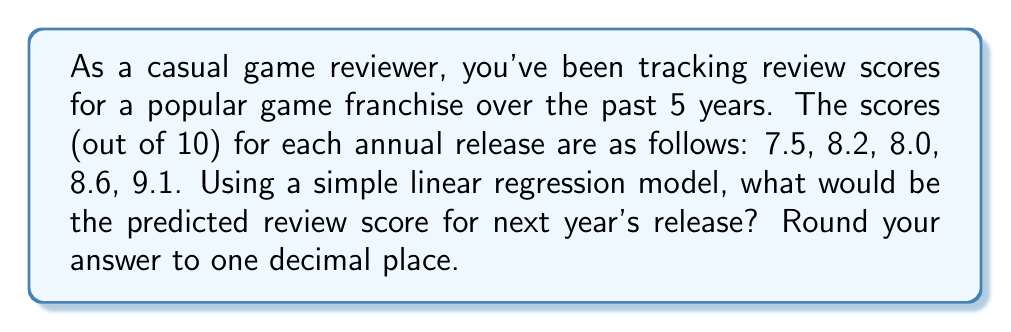Teach me how to tackle this problem. To solve this problem, we'll use a simple linear regression model to identify the trend in game review scores over time. Here's how we'll approach it:

1. Assign time values (x) to each year, starting with 1 for the first year:
   x: 1, 2, 3, 4, 5
   y: 7.5, 8.2, 8.0, 8.6, 9.1

2. Calculate the means of x and y:
   $\bar{x} = \frac{1 + 2 + 3 + 4 + 5}{5} = 3$
   $\bar{y} = \frac{7.5 + 8.2 + 8.0 + 8.6 + 9.1}{5} = 8.28$

3. Calculate the slope (b) of the regression line:
   $b = \frac{\sum(x_i - \bar{x})(y_i - \bar{y})}{\sum(x_i - \bar{x})^2}$

   $\sum(x_i - \bar{x})(y_i - \bar{y}) = (-2)(7.5-8.28) + (-1)(8.2-8.28) + (0)(8.0-8.28) + (1)(8.6-8.28) + (2)(9.1-8.28) = 3.9$
   $\sum(x_i - \bar{x})^2 = (-2)^2 + (-1)^2 + 0^2 + 1^2 + 2^2 = 10$

   $b = \frac{3.9}{10} = 0.39$

4. Calculate the y-intercept (a):
   $a = \bar{y} - b\bar{x} = 8.28 - 0.39(3) = 7.11$

5. The linear regression equation is:
   $y = 7.11 + 0.39x$

6. To predict the score for next year (year 6), we substitute x = 6:
   $y = 7.11 + 0.39(6) = 9.45$

Rounding to one decimal place, we get 9.5.
Answer: 9.5 